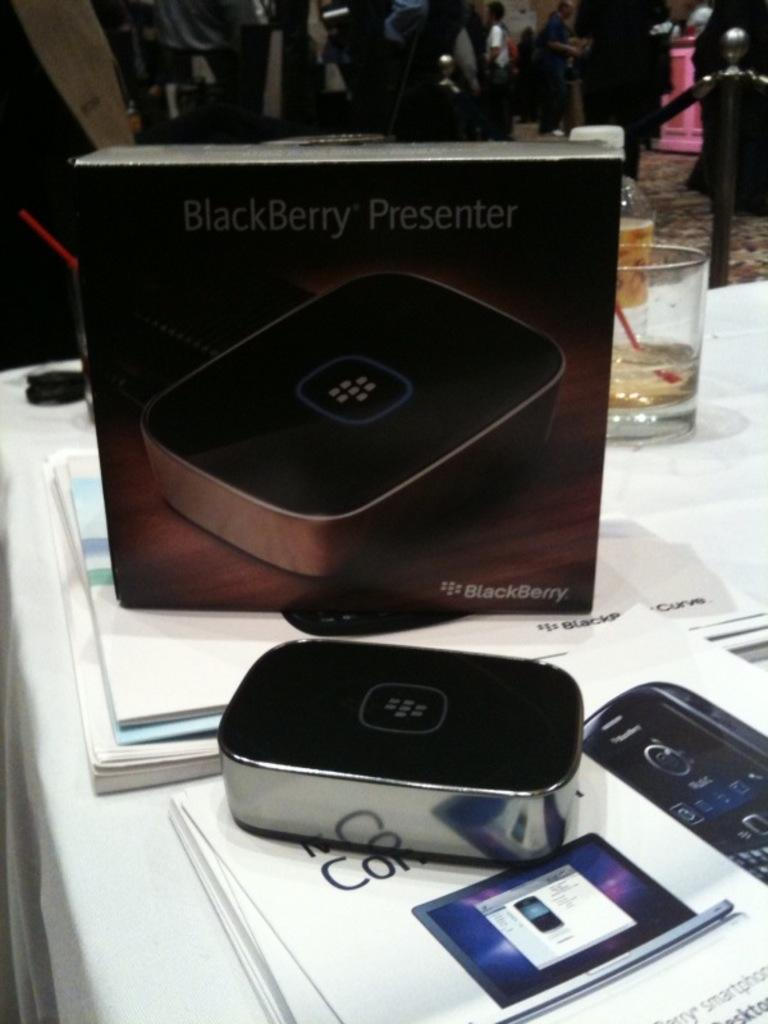<image>
Describe the image concisely. The new BlackBerry Presenter and the box that it comes in. 